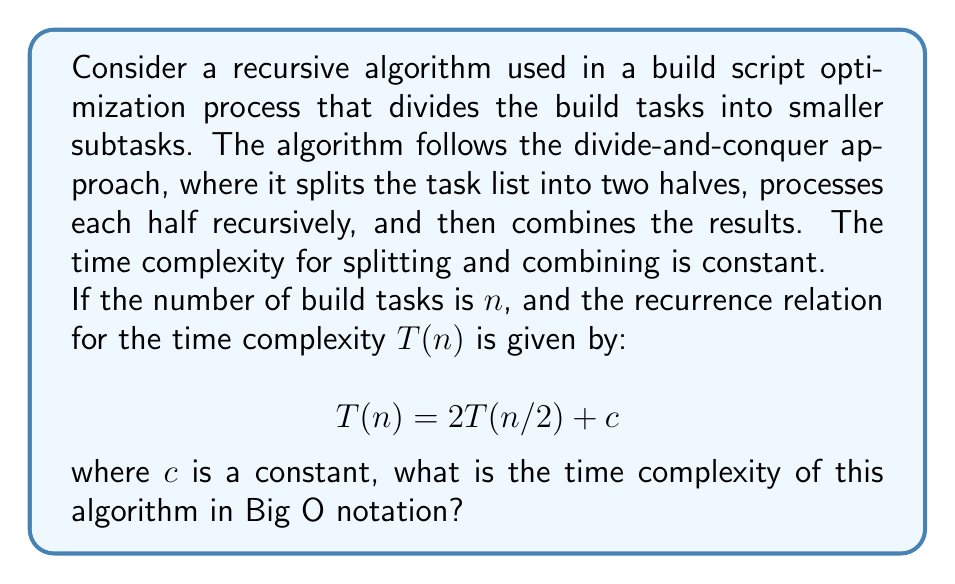Could you help me with this problem? To solve this problem, we'll use the Master Theorem, which is commonly used to analyze the time complexity of divide-and-conquer algorithms.

The Master Theorem states that for a recurrence relation of the form:

$$T(n) = aT(n/b) + f(n)$$

where $a \geq 1$, $b > 1$, and $f(n)$ is a positive function, the time complexity can be determined by comparing $f(n)$ with $n^{\log_b a}$.

In our case:
$a = 2$ (number of recursive calls)
$b = 2$ (input size is halved in each recursive call)
$f(n) = c$ (constant time for splitting and combining)

First, let's calculate $n^{\log_b a}$:

$$n^{\log_b a} = n^{\log_2 2} = n^1 = n$$

Now, we compare $f(n) = c$ with $n^{\log_b a} = n$:

Since $f(n) = c$ is $O(n^{\log_b a - \epsilon})$ for any $\epsilon > 0$, we fall into case 2 of the Master Theorem.

Case 2 states that if $f(n) = \Theta(n^{\log_b a})$, then:

$$T(n) = \Theta(n^{\log_b a} \log n)$$

Substituting our values:

$$T(n) = \Theta(n \log n)$$

Therefore, the time complexity of the algorithm is $\Theta(n \log n)$, which is equivalent to $O(n \log n)$ in Big O notation.
Answer: $O(n \log n)$ 